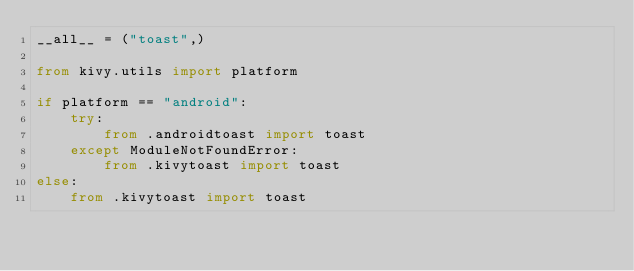<code> <loc_0><loc_0><loc_500><loc_500><_Python_>__all__ = ("toast",)

from kivy.utils import platform

if platform == "android":
    try:
        from .androidtoast import toast
    except ModuleNotFoundError:
        from .kivytoast import toast
else:
    from .kivytoast import toast
</code> 